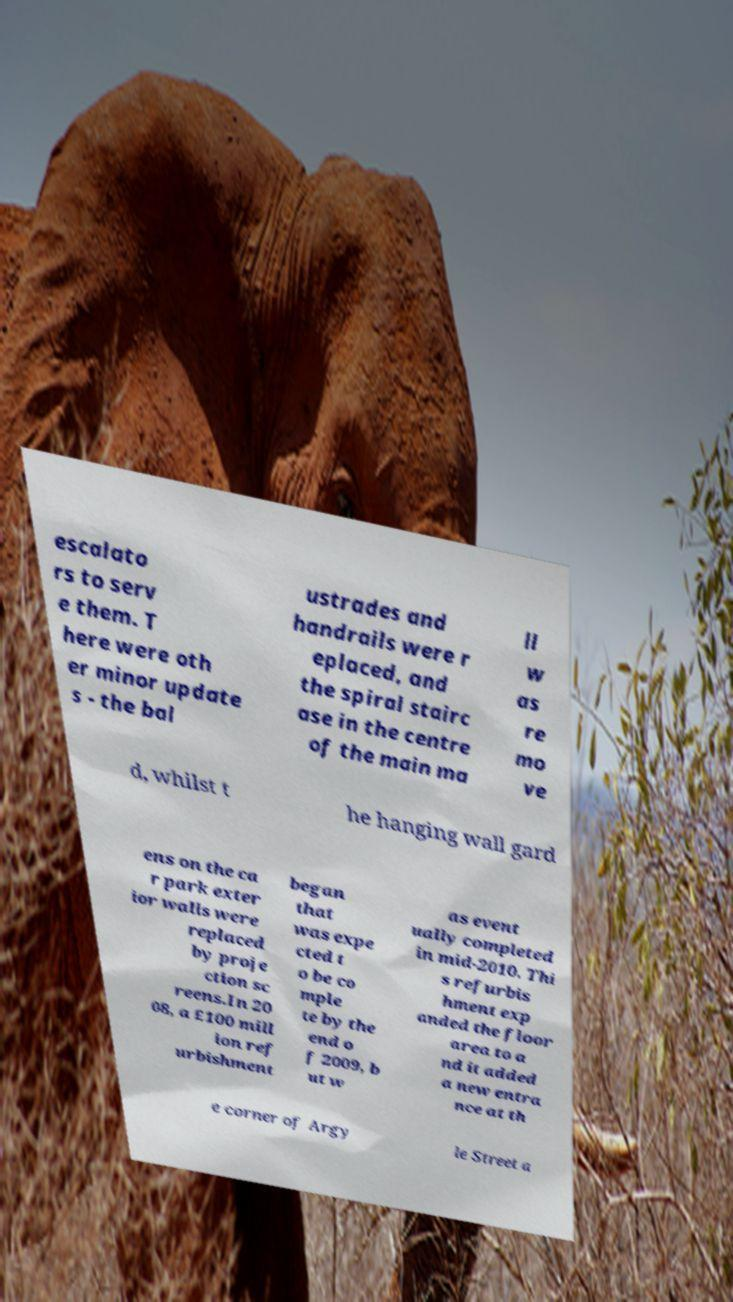Please identify and transcribe the text found in this image. escalato rs to serv e them. T here were oth er minor update s - the bal ustrades and handrails were r eplaced, and the spiral stairc ase in the centre of the main ma ll w as re mo ve d, whilst t he hanging wall gard ens on the ca r park exter ior walls were replaced by proje ction sc reens.In 20 08, a £100 mill ion ref urbishment began that was expe cted t o be co mple te by the end o f 2009, b ut w as event ually completed in mid-2010. Thi s refurbis hment exp anded the floor area to a nd it added a new entra nce at th e corner of Argy le Street a 